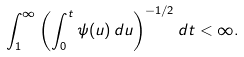Convert formula to latex. <formula><loc_0><loc_0><loc_500><loc_500>\int _ { 1 } ^ { \infty } \left ( \int _ { 0 } ^ { t } \psi ( u ) \, d u \right ) ^ { - 1 / 2 } d t < \infty .</formula> 